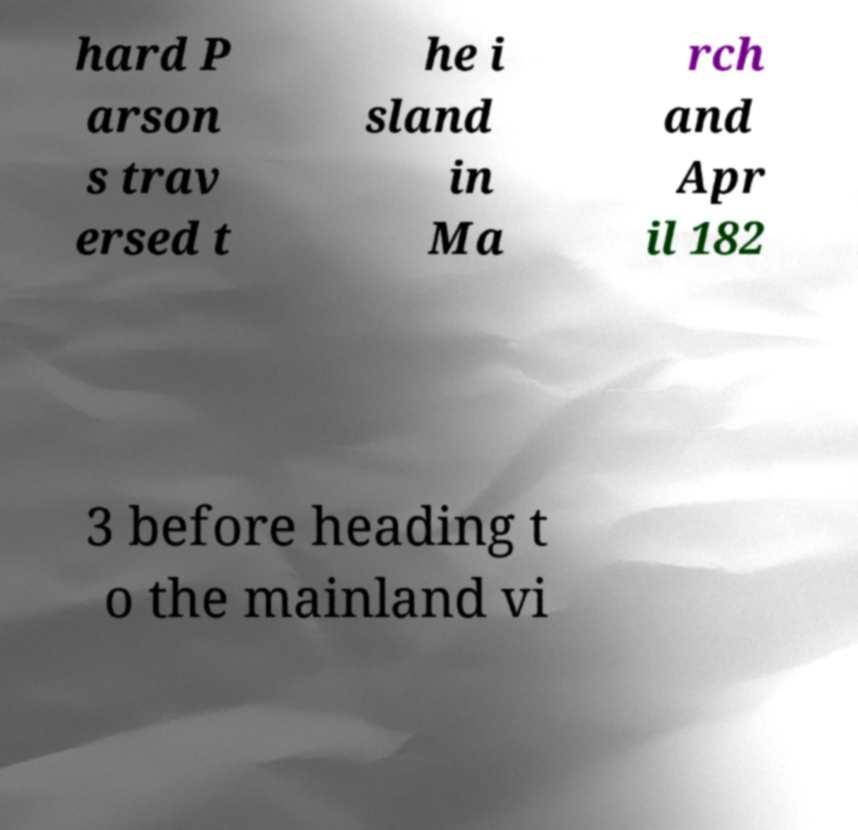For documentation purposes, I need the text within this image transcribed. Could you provide that? hard P arson s trav ersed t he i sland in Ma rch and Apr il 182 3 before heading t o the mainland vi 